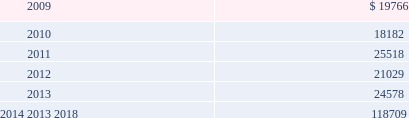Mastercard incorporated notes to consolidated financial statements 2014 ( continued ) ( in thousands , except percent and per share data ) the table summarizes expected benefit payments through 2018 including those payments expected to be paid from the company 2019s general assets .
Since the majority of the benefit payments are made in the form of lump-sum distributions , actual benefit payments may differ from expected benefits payments. .
Substantially all of the company 2019s u.s .
Employees are eligible to participate in a defined contribution savings plan ( the 201csavings plan 201d ) sponsored by the company .
The savings plan allows employees to contribute a portion of their base compensation on a pre-tax and after-tax basis in accordance with specified guidelines .
The company matches a percentage of employees 2019 contributions up to certain limits .
In 2007 and prior years , the company could also contribute to the savings plan a discretionary profit sharing component linked to company performance during the prior year .
Beginning in 2008 , the discretionary profit sharing amount related to 2007 company performance was paid directly to employees as a short-term cash incentive bonus rather than as a contribution to the savings plan .
In addition , the company has several defined contribution plans outside of the united states .
The company 2019s contribution expense related to all of its defined contribution plans was $ 35341 , $ 26996 and $ 43594 for 2008 , 2007 and 2006 , respectively .
The company had a value appreciation program ( 201cvap 201d ) , which was an incentive compensation plan established in 1995 .
Annual awards were granted to vap participants from 1995 through 1998 , which entitled participants to the net appreciation on a portfolio of securities of members of mastercard international .
In 1999 , the vap was replaced by an executive incentive plan ( 201ceip 201d ) and the senior executive incentive plan ( 201cseip 201d ) ( together the 201ceip plans 201d ) ( see note 16 ( share based payments and other benefits ) ) .
Contributions to the vap have been discontinued , all plan assets have been disbursed and no vap liability remained as of december 31 , 2008 .
The company 2019s liability related to the vap at december 31 , 2007 was $ 986 .
The expense ( benefit ) was $ ( 6 ) , $ ( 267 ) and $ 3406 for the years ended december 31 , 2008 , 2007 and 2006 , respectively .
Note 12 .
Postemployment and postretirement benefits the company maintains a postretirement plan ( the 201cpostretirement plan 201d ) providing health coverage and life insurance benefits for substantially all of its u.s .
Employees and retirees hired before july 1 , 2007 .
The company amended the life insurance benefits under the postretirement plan effective january 1 , 2007 .
The impact , net of taxes , of this amendment was an increase of $ 1715 to accumulated other comprehensive income in 2007. .
What was the ratio of the company 2019s contribution expense related to all of its defined contribution plans for 2008 to 2007? 
Rationale: the ratio of the company 2019s contribution expense related to all of its defined contribution plans for 2008 to 2007 was 1.31 to 1
Computations: (35341 / 26996)
Answer: 1.30912. 